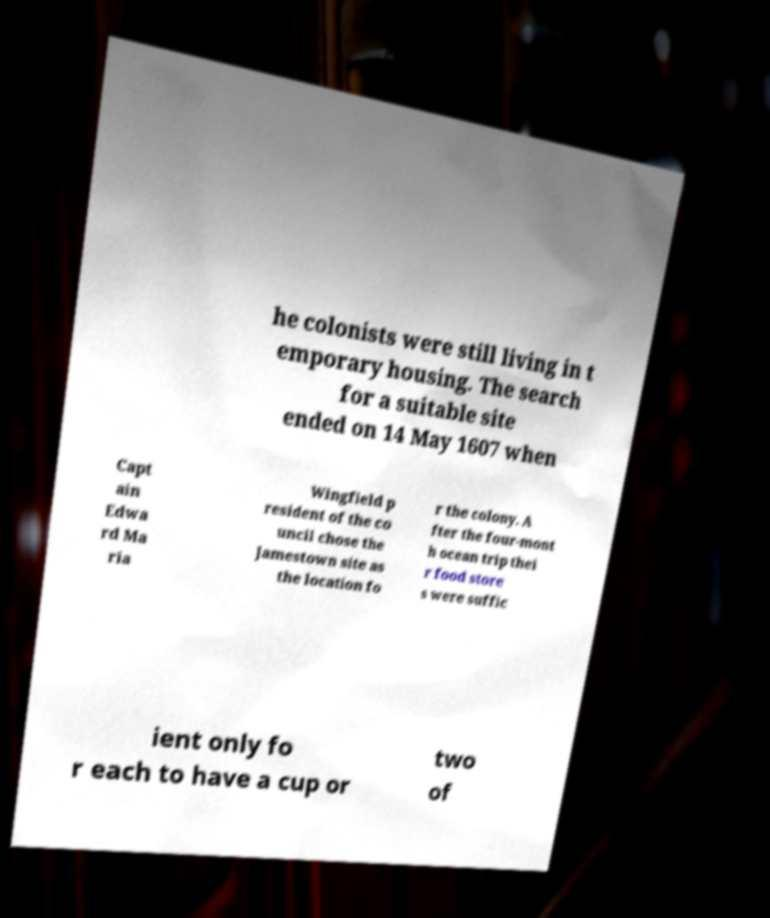For documentation purposes, I need the text within this image transcribed. Could you provide that? he colonists were still living in t emporary housing. The search for a suitable site ended on 14 May 1607 when Capt ain Edwa rd Ma ria Wingfield p resident of the co uncil chose the Jamestown site as the location fo r the colony. A fter the four-mont h ocean trip thei r food store s were suffic ient only fo r each to have a cup or two of 